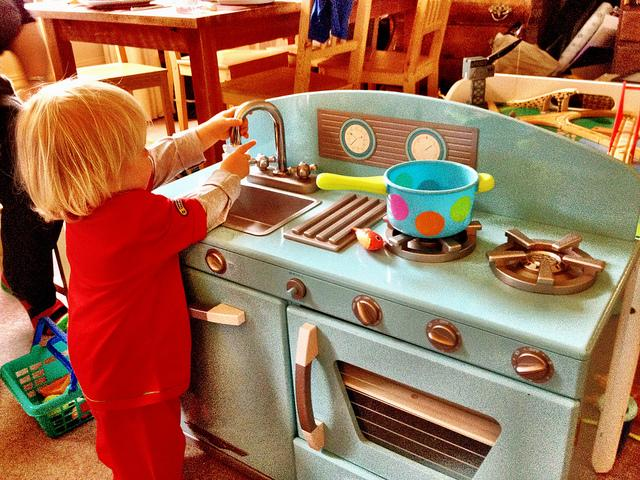What will come out of the sink? Please explain your reasoning. nothing. The play stove does not have a real water source. 